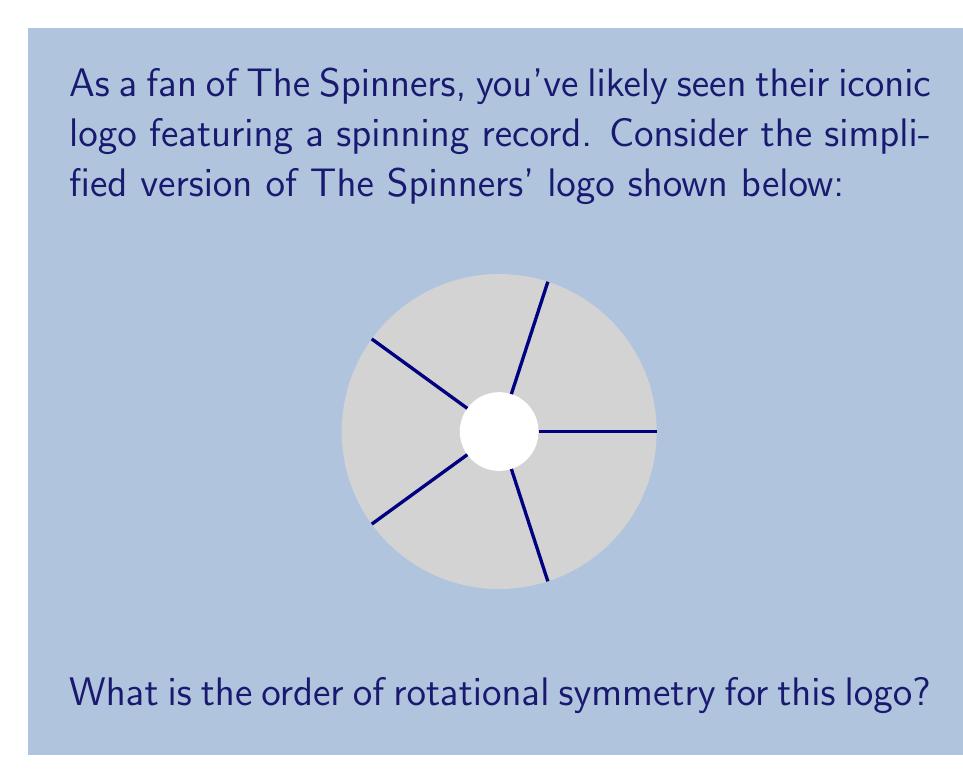Show me your answer to this math problem. To determine the order of rotational symmetry, we need to follow these steps:

1) Observe the logo carefully. It consists of a circular record with 5 equally spaced lines radiating from the center.

2) Rotational symmetry occurs when an object can be rotated about its center by a certain angle, and it appears identical to its original position.

3) In this case, we need to find how many times we can rotate the logo so that it looks the same as the original.

4) The angle of rotation that brings the logo back to its original appearance is:

   $$\text{Angle of rotation} = \frac{360°}{\text{Number of identical positions}}$$

5) We can see that rotating the logo by $\frac{360°}{5} = 72°$ will bring one line to the position of the next, making the logo look identical.

6) This means we can rotate the logo 5 times (0°, 72°, 144°, 216°, 288°) before it completes a full 360° rotation and returns to its original position.

7) Therefore, the order of rotational symmetry is 5.
Answer: 5 